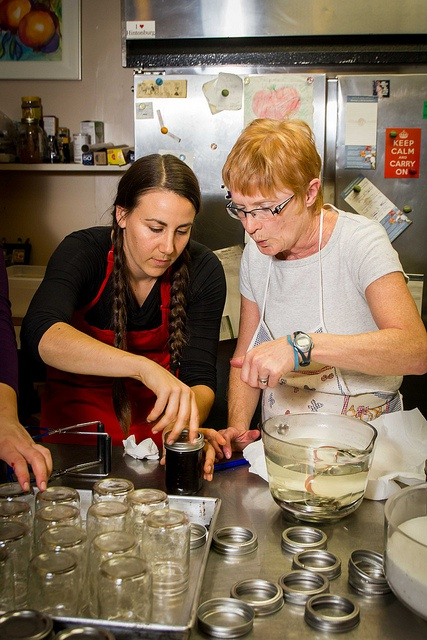Describe the objects in this image and their specific colors. I can see refrigerator in maroon, lightgray, black, gray, and tan tones, people in maroon, lightgray, tan, and brown tones, people in maroon, black, and tan tones, bowl in maroon, tan, and lightgray tones, and bowl in maroon, tan, and gray tones in this image. 